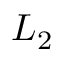Convert formula to latex. <formula><loc_0><loc_0><loc_500><loc_500>L _ { 2 }</formula> 